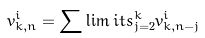Convert formula to latex. <formula><loc_0><loc_0><loc_500><loc_500>v _ { k , n } ^ { i } = \sum \lim i t s _ { j = 2 } ^ { k } v _ { k , n - j } ^ { i } \</formula> 